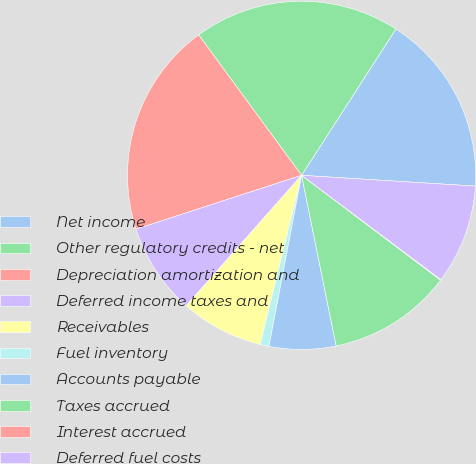Convert chart to OTSL. <chart><loc_0><loc_0><loc_500><loc_500><pie_chart><fcel>Net income<fcel>Other regulatory credits - net<fcel>Depreciation amortization and<fcel>Deferred income taxes and<fcel>Receivables<fcel>Fuel inventory<fcel>Accounts payable<fcel>Taxes accrued<fcel>Interest accrued<fcel>Deferred fuel costs<nl><fcel>16.88%<fcel>19.18%<fcel>19.94%<fcel>8.47%<fcel>7.71%<fcel>0.82%<fcel>6.18%<fcel>11.53%<fcel>0.06%<fcel>9.24%<nl></chart> 